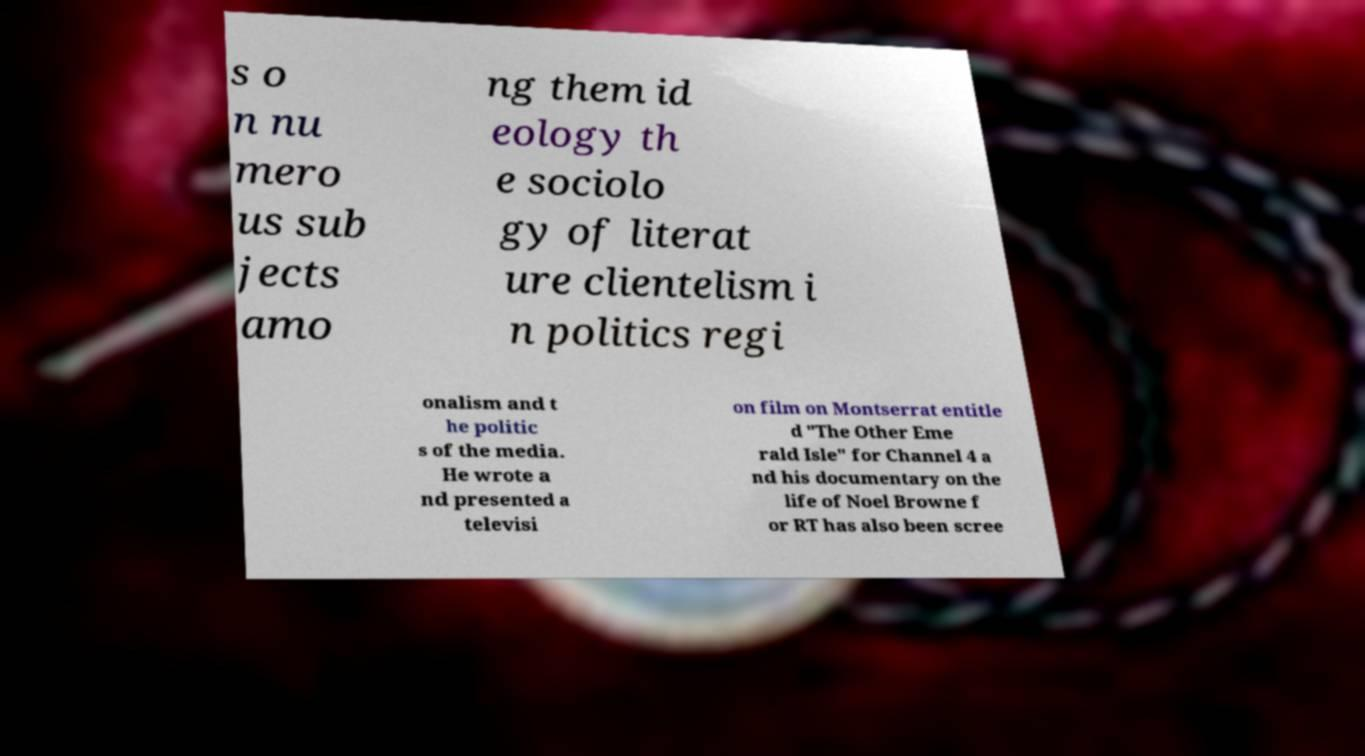Please read and relay the text visible in this image. What does it say? s o n nu mero us sub jects amo ng them id eology th e sociolo gy of literat ure clientelism i n politics regi onalism and t he politic s of the media. He wrote a nd presented a televisi on film on Montserrat entitle d "The Other Eme rald Isle" for Channel 4 a nd his documentary on the life of Noel Browne f or RT has also been scree 